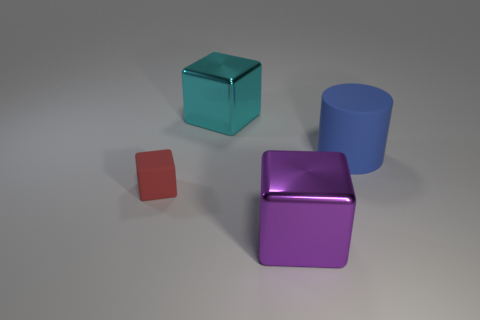Add 2 small purple metal cubes. How many objects exist? 6 Subtract all cubes. How many objects are left? 1 Subtract 0 cyan cylinders. How many objects are left? 4 Subtract all cyan blocks. Subtract all small red cubes. How many objects are left? 2 Add 2 red rubber blocks. How many red rubber blocks are left? 3 Add 4 large cyan metal cubes. How many large cyan metal cubes exist? 5 